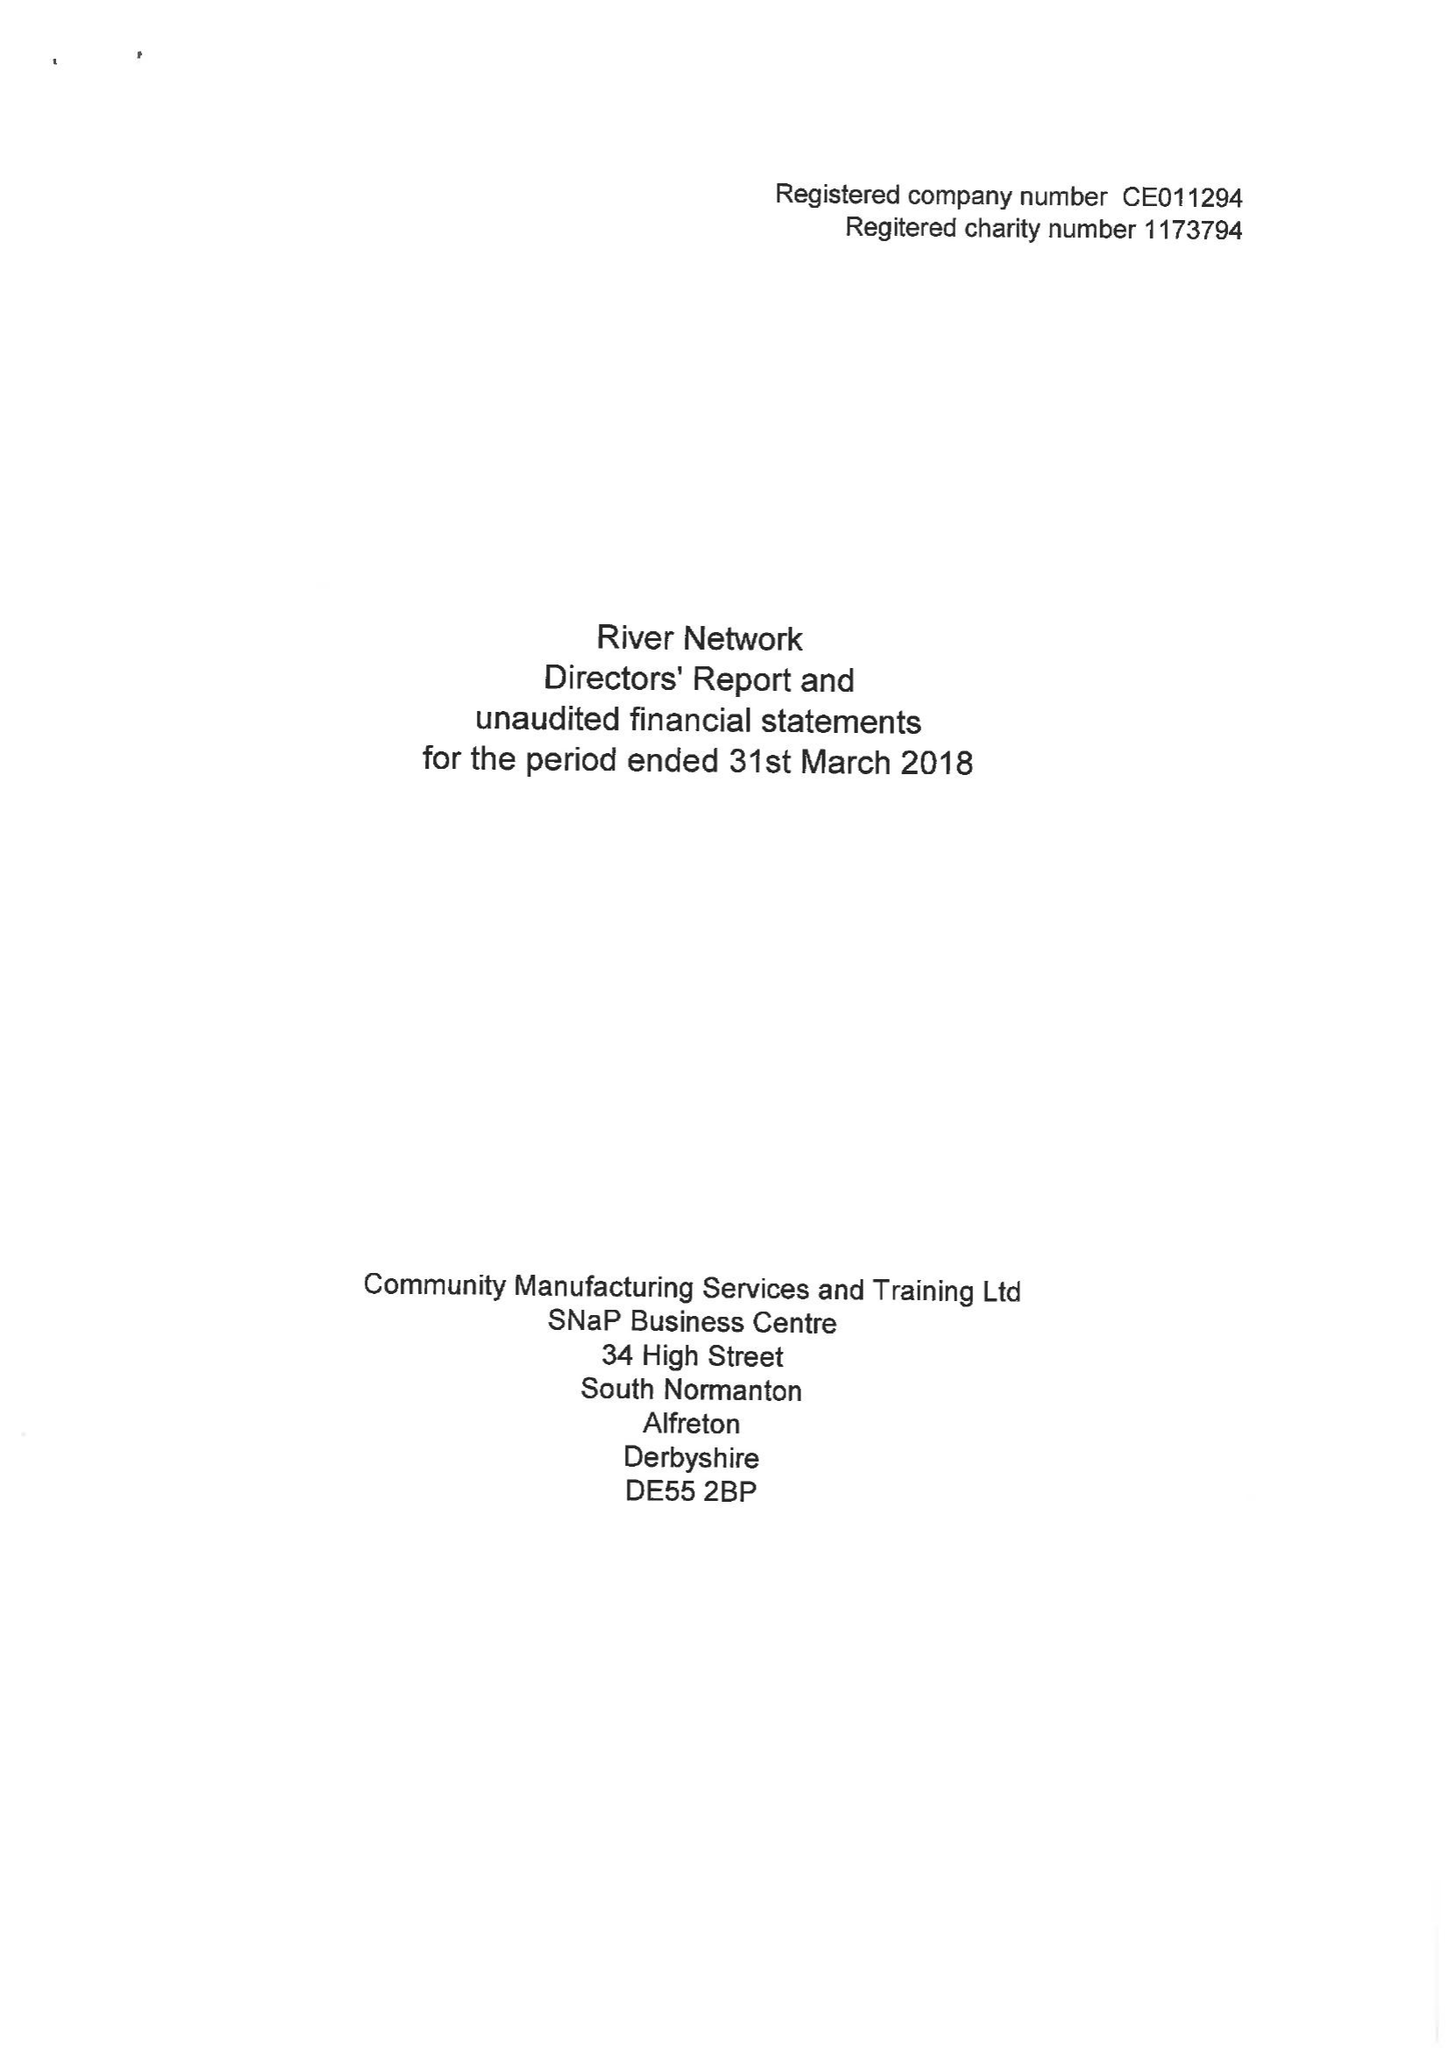What is the value for the charity_number?
Answer the question using a single word or phrase. 1173794 